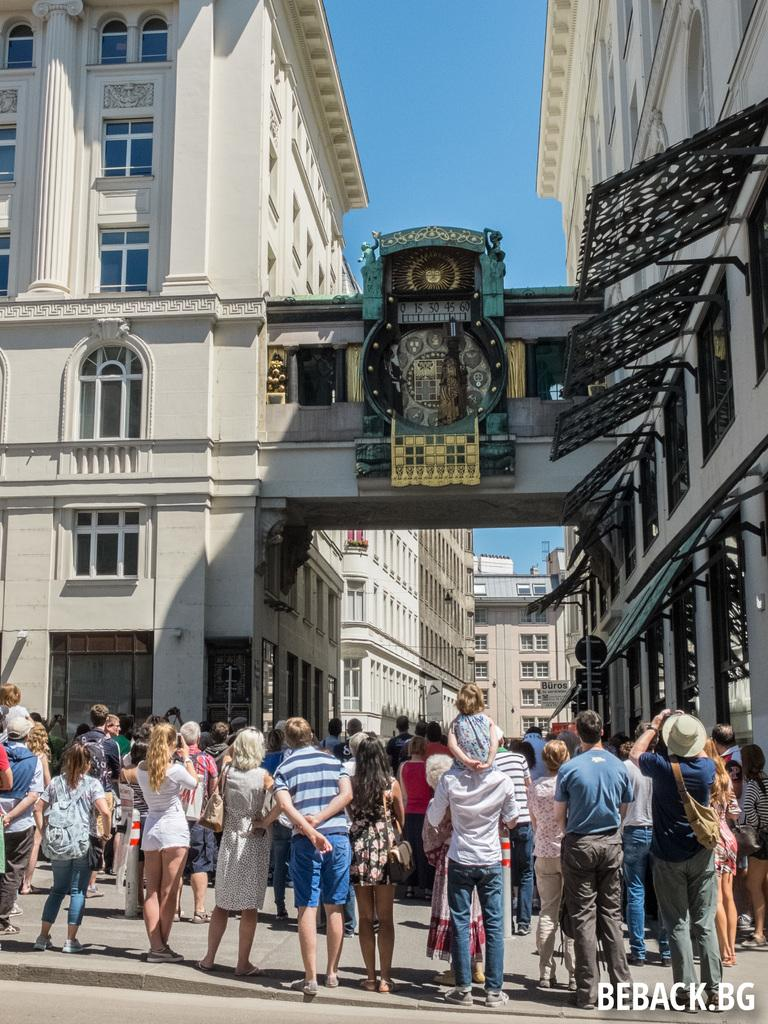What is the main structure in the image? There is a building in the image. What is happening in front of the building? There is a group of persons in front of the building. What can be seen at the top of the image? The sky is visible at the top of the image. Where is the text located in the image? The text is in the bottom right corner of the image. What type of fruit is being harvested at the plantation in the image? There is no plantation or fruit present in the image; it features a building with a group of persons in front of it and text in the bottom right corner. 